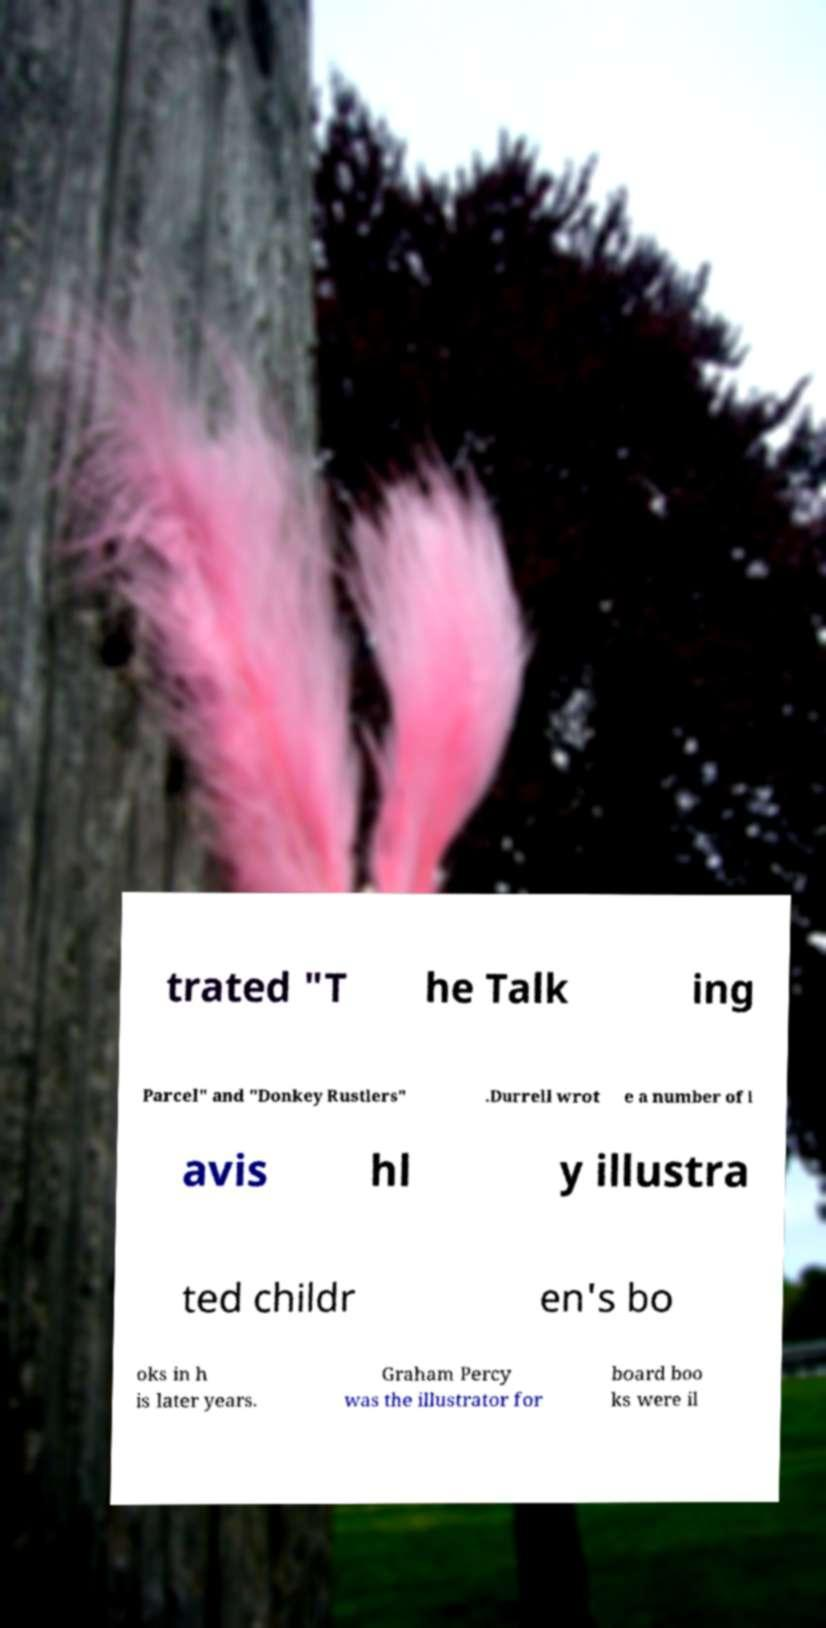Can you read and provide the text displayed in the image?This photo seems to have some interesting text. Can you extract and type it out for me? trated "T he Talk ing Parcel" and "Donkey Rustlers" .Durrell wrot e a number of l avis hl y illustra ted childr en's bo oks in h is later years. Graham Percy was the illustrator for board boo ks were il 